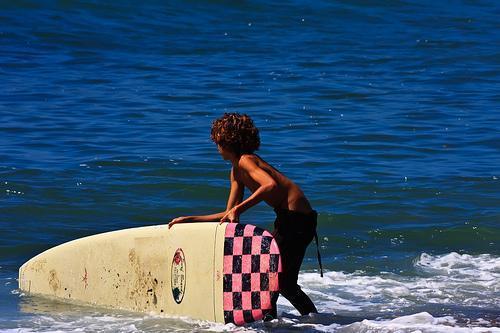How many boys are pictured?
Give a very brief answer. 1. 